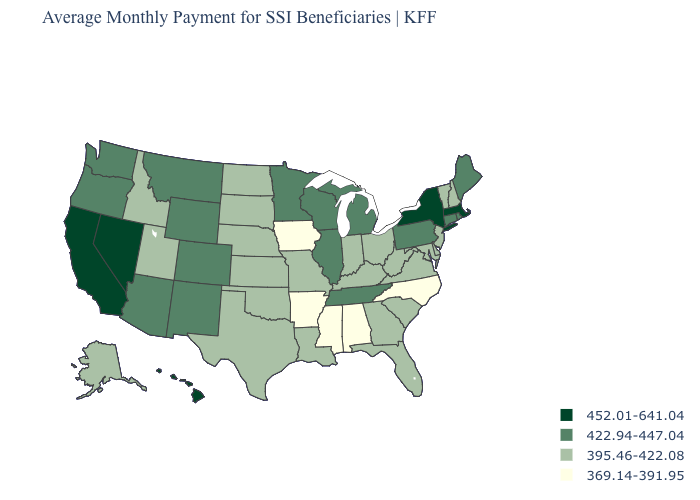Name the states that have a value in the range 452.01-641.04?
Quick response, please. California, Hawaii, Massachusetts, Nevada, New York. How many symbols are there in the legend?
Be succinct. 4. Name the states that have a value in the range 369.14-391.95?
Answer briefly. Alabama, Arkansas, Iowa, Mississippi, North Carolina. Name the states that have a value in the range 395.46-422.08?
Write a very short answer. Alaska, Delaware, Florida, Georgia, Idaho, Indiana, Kansas, Kentucky, Louisiana, Maryland, Missouri, Nebraska, New Hampshire, New Jersey, North Dakota, Ohio, Oklahoma, South Carolina, South Dakota, Texas, Utah, Vermont, Virginia, West Virginia. Does the first symbol in the legend represent the smallest category?
Be succinct. No. Name the states that have a value in the range 369.14-391.95?
Quick response, please. Alabama, Arkansas, Iowa, Mississippi, North Carolina. Name the states that have a value in the range 422.94-447.04?
Short answer required. Arizona, Colorado, Connecticut, Illinois, Maine, Michigan, Minnesota, Montana, New Mexico, Oregon, Pennsylvania, Rhode Island, Tennessee, Washington, Wisconsin, Wyoming. Which states hav the highest value in the Northeast?
Concise answer only. Massachusetts, New York. Does Georgia have a higher value than Connecticut?
Concise answer only. No. Does Nebraska have the highest value in the USA?
Answer briefly. No. Does Washington have a higher value than South Carolina?
Concise answer only. Yes. How many symbols are there in the legend?
Answer briefly. 4. Does New Mexico have a lower value than Washington?
Quick response, please. No. What is the lowest value in states that border Michigan?
Give a very brief answer. 395.46-422.08. Does Iowa have the same value as Hawaii?
Write a very short answer. No. 